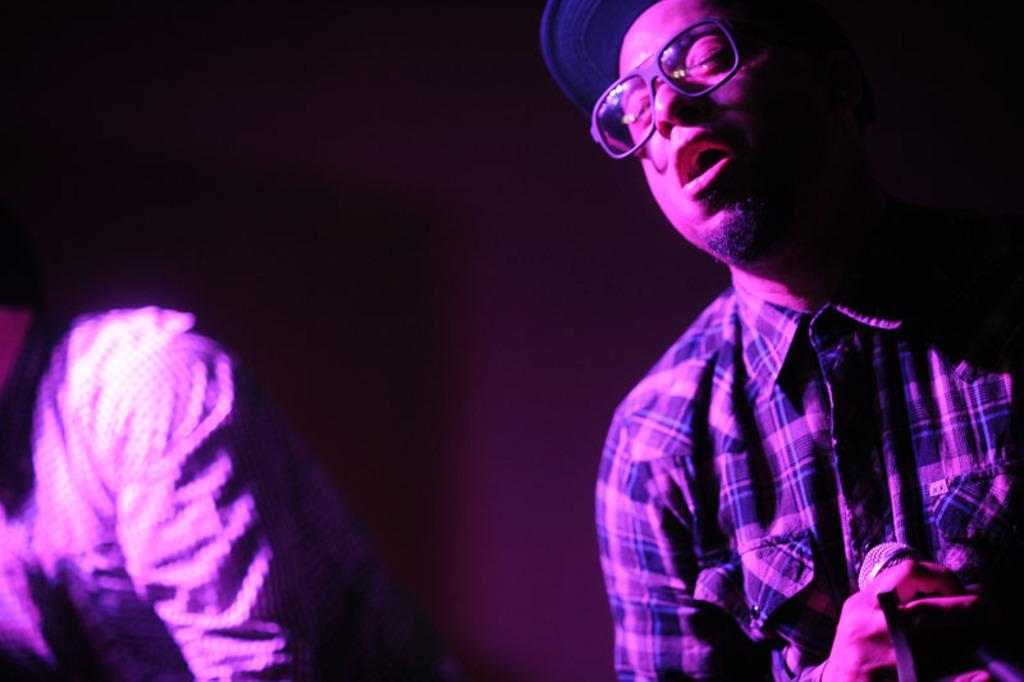How many people are in the image? There are two men in the image. What is the man on the left side holding? The man on the left side is holding a microphone. Can you describe the appearance of the man on the left side? The man on the left side is wearing glasses. What type of writing can be seen on the skirt of the man on the right side? There is no man on the right side in the image, and there is no mention of a skirt. 